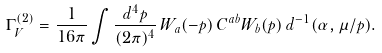Convert formula to latex. <formula><loc_0><loc_0><loc_500><loc_500>\Gamma _ { V } ^ { ( 2 ) } = \frac { 1 } { 1 6 \pi } \int \frac { d ^ { 4 } p } { ( 2 \pi ) ^ { 4 } } \, W _ { a } ( - p ) \, C ^ { a b } W _ { b } ( p ) \, d ^ { - 1 } ( \alpha , \mu / p ) .</formula> 